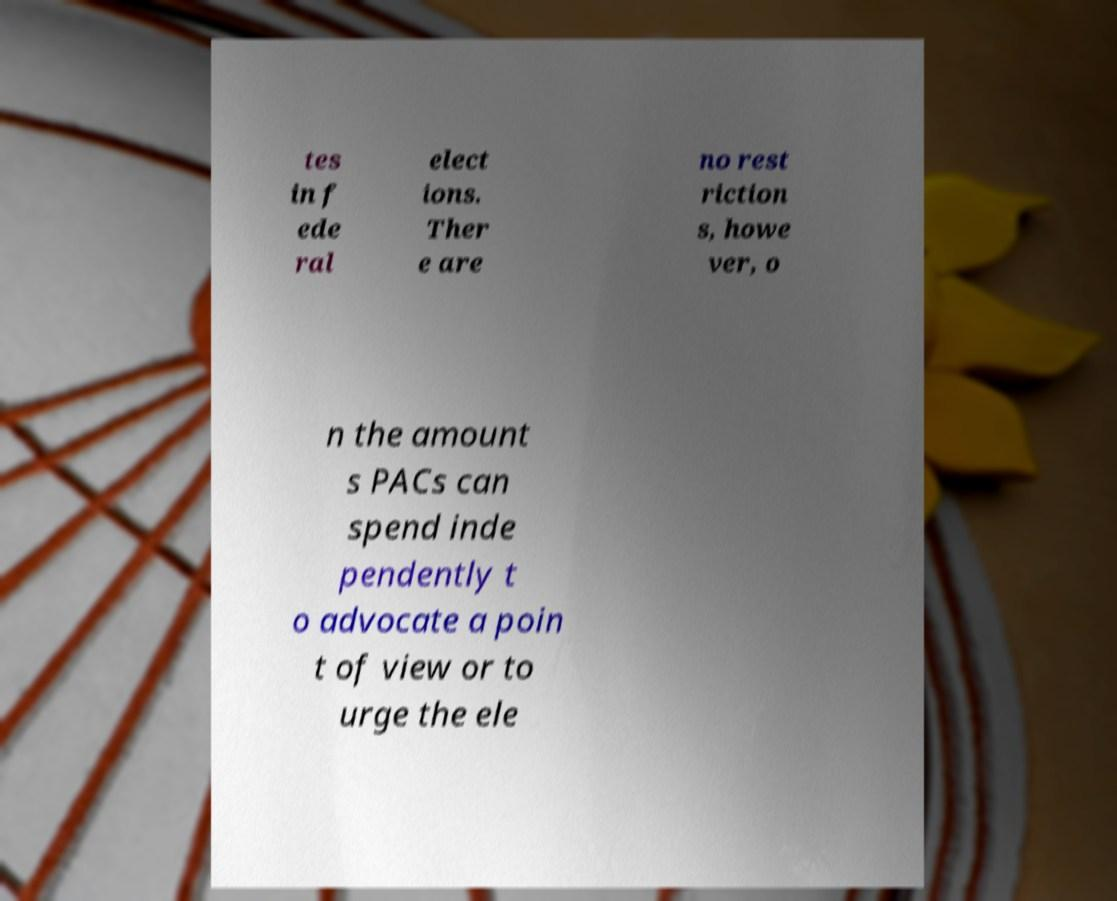For documentation purposes, I need the text within this image transcribed. Could you provide that? tes in f ede ral elect ions. Ther e are no rest riction s, howe ver, o n the amount s PACs can spend inde pendently t o advocate a poin t of view or to urge the ele 